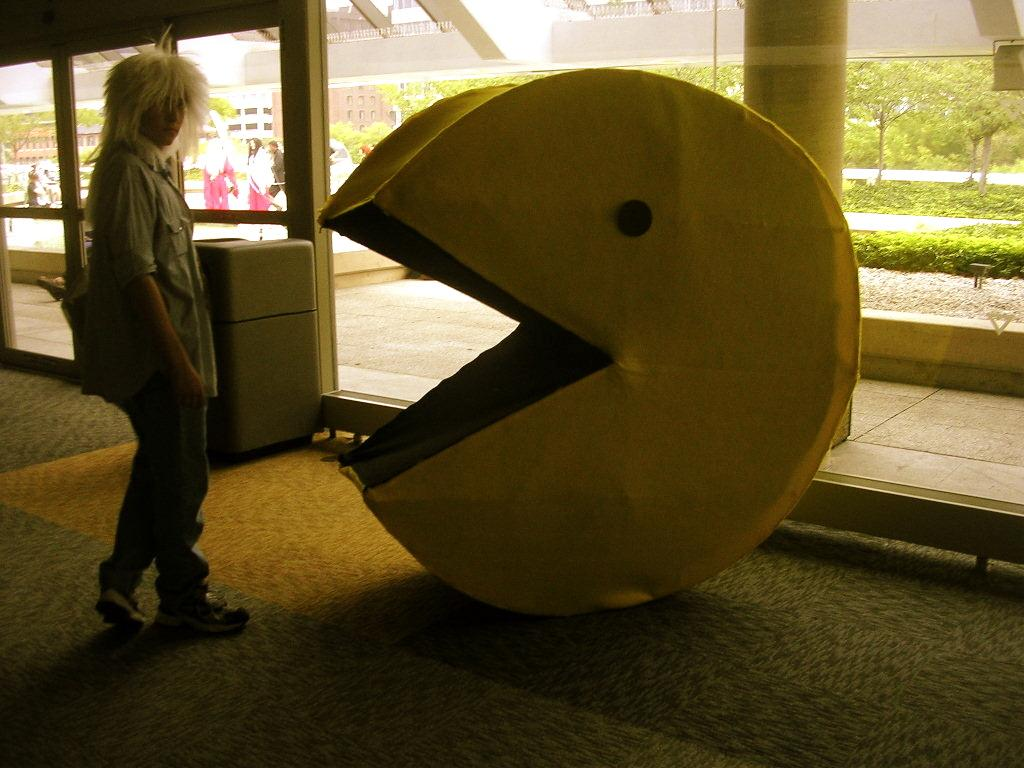What is the person in the image wearing? There is a person with a dress in the image. What is in front of the person? There is an object in front of the person. Can you describe the background of the image? There are more people, trees, and buildings in the background of the image. How does the person in the image use their credit card to make a purchase? There is no credit card or purchase activity depicted in the image. 